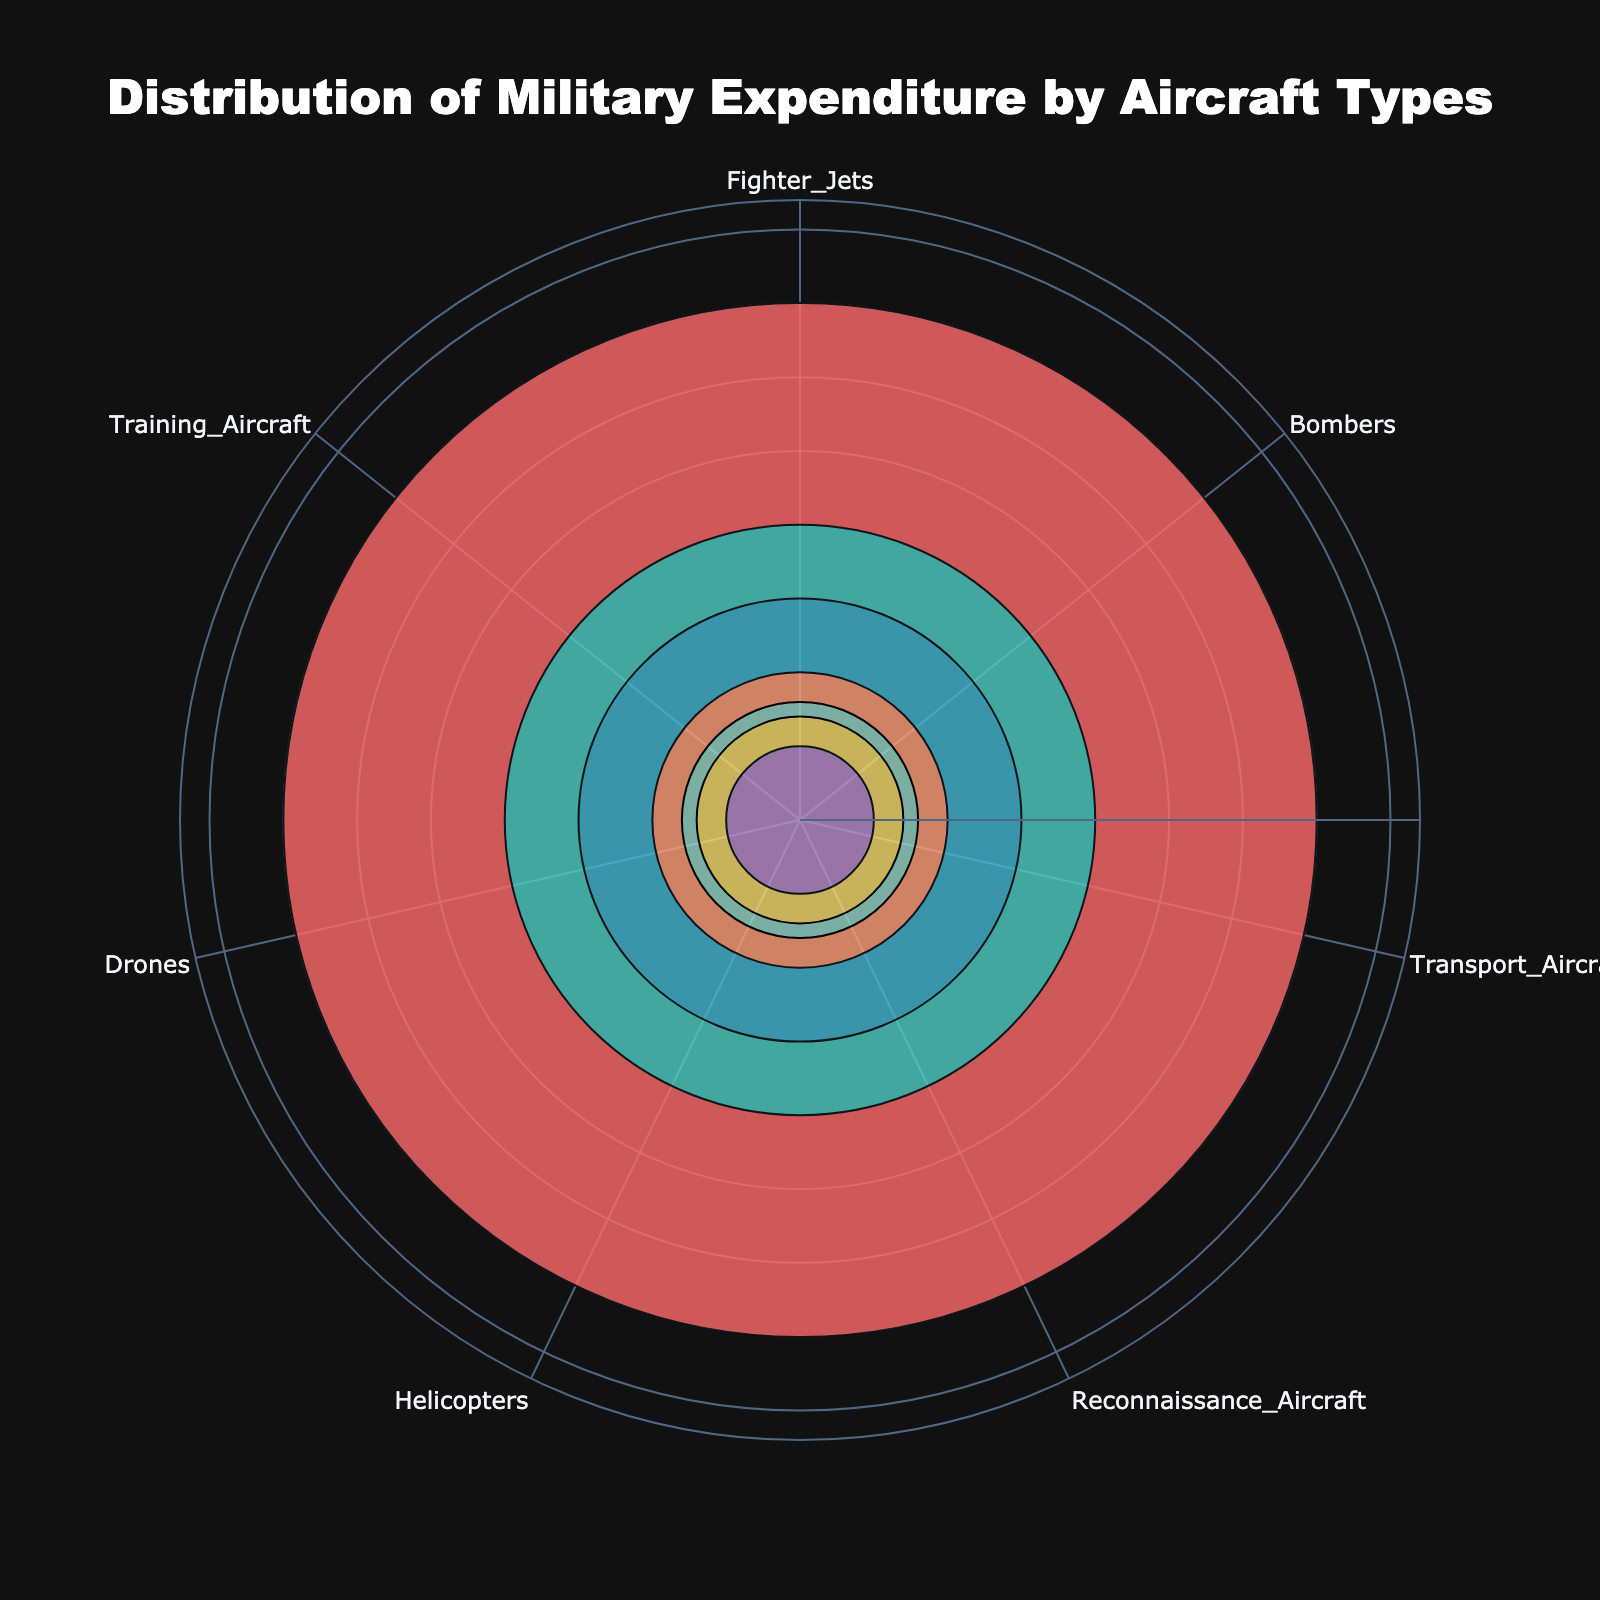What is the title of the figure? The title is usually placed at the top of the figure and in this chart, it is clearly stated as "Distribution of Military Expenditure by Aircraft Types".
Answer: Distribution of Military Expenditure by Aircraft Types Which aircraft type received the highest military expenditure? By observing the lengths of the bars, the Fighter Jets bar is the longest, indicating it has the highest spending.
Answer: Fighter Jets How do the spending percentages for Bombers and Transport Aircraft compare? Bombers have a spending percentage of 20%, while Transport Aircraft have 15%. 20% is greater than 15%.
Answer: Bombers What is the combined expenditure percentage for Drones and Helicopters? The spending for Drones is 7% and for Helicopters is 8%. Adding these two together (7% + 8%) gives 15%.
Answer: 15% Which aircraft type received the least expenditure? The Training Aircraft bar is the shortest, indicating it has the lowest spending percentage of 5%.
Answer: Training Aircraft How many aircraft types are represented in this chart? Counting the distinct bars in the polar chart gives a total of 7 different aircraft types.
Answer: 7 What is the average expenditure percentage across all aircraft types? To find the average, sum up all the spending percentages (35 + 20 + 15 + 10 + 8 + 7 + 5) which equals 100, then divide by the number of aircraft types (7). The average is 100 / 7 ≈ 14.29%.
Answer: 14.29% What is the radial range set in the chart? The maximum spending percentage is 35%, and the radial range is extended to 1.2 times the maximum, giving a total range of 0 to 42.
Answer: 0 to 42 If Bombers' expenditure were increased by 10%, what would the new total expenditure be? Bombers currently have 20%, adding 10% makes it 30%. The new total expenditure would thus be 35 (Fighter Jets) + 30 (Bombers) + 15 (Transport) + 10 (Recon) + 8 (Helicopters) + 7 (Drones) + 5 (Training) = 110%.
Answer: 110% Why might the Fighter Jets receive the highest spending relative to other aircraft types? Typically, Fighter Jets are crucial for air superiority and advanced combat missions, often requiring significant investment in technology and maintenance, which justifies their larger expenditure.
Answer: Essential for advanced combat missions and air superiority 